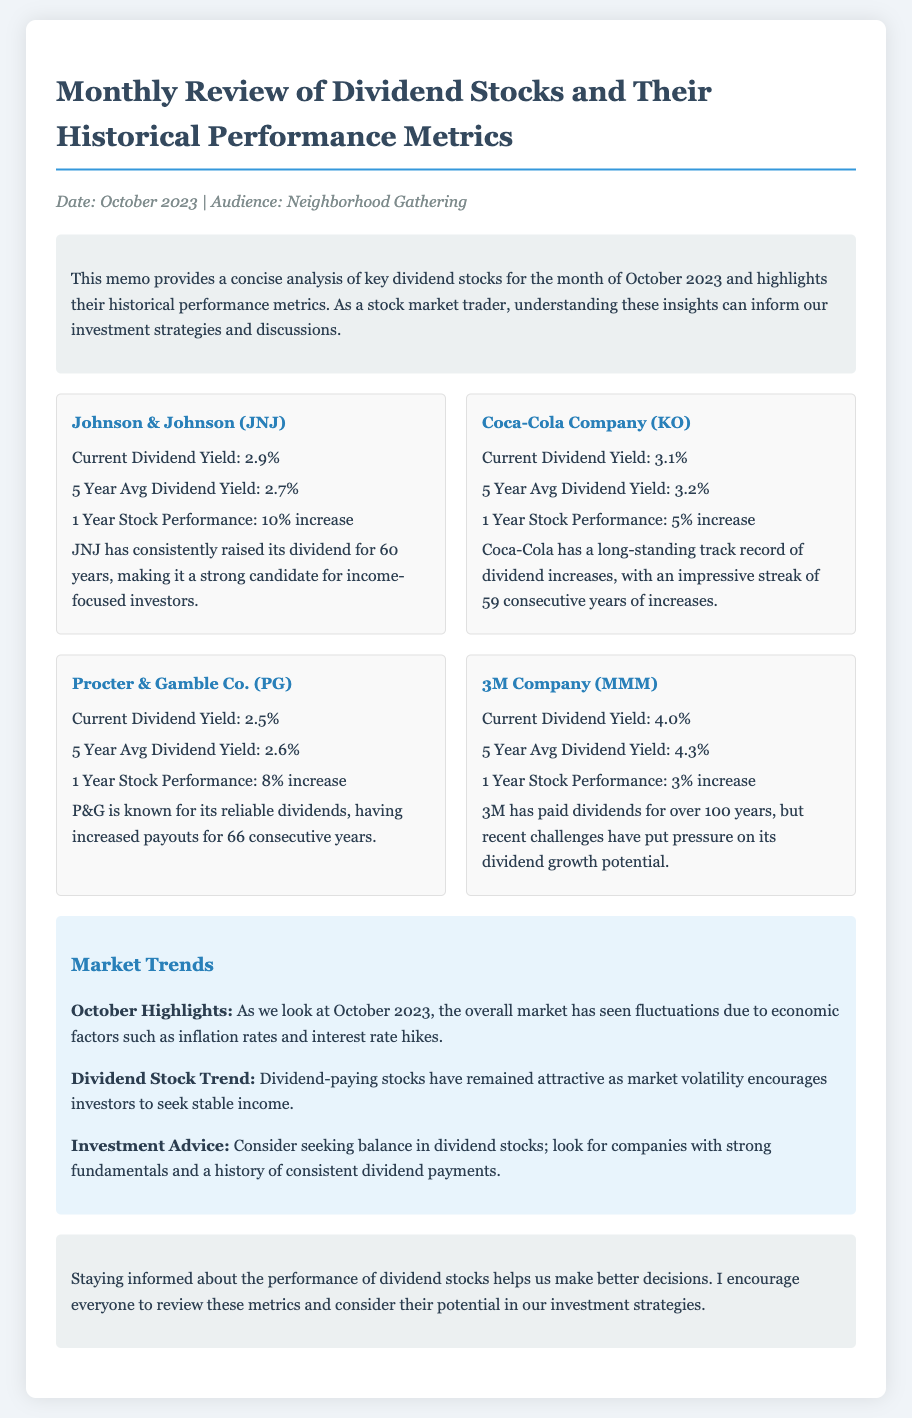What is the current dividend yield for Johnson & Johnson? Johnson & Johnson's current dividend yield is listed in the document, which states 2.9%.
Answer: 2.9% How long has Coca-Cola Company increased its dividends? The document mentions that Coca-Cola has an impressive streak of increases for 59 consecutive years.
Answer: 59 years What was the 1 year stock performance of Procter & Gamble Co.? The memo states that Procter & Gamble Co. had an 8% increase in stock performance over the past year.
Answer: 8% increase What is the 5 year average dividend yield for 3M Company? The document specifically states the 5 year average dividend yield for 3M Company is 4.3%.
Answer: 4.3% What is a key market trend observed in October 2023? The memo highlights that the overall market has seen fluctuations due to economic factors like inflation rates and interest rate hikes.
Answer: Fluctuations How many years has JNJ consistently raised its dividends? The document clearly states that Johnson & Johnson has raised its dividend for 60 years.
Answer: 60 years What are investors encouraged to seek in dividend stocks? The document gives investment advice suggesting that investors should look for companies with strong fundamentals and a consistent dividend payment history.
Answer: Strong fundamentals What is the conclusion's main recommendation? The conclusion encourages readers to review the metrics for better investment decisions.
Answer: Review the metrics 